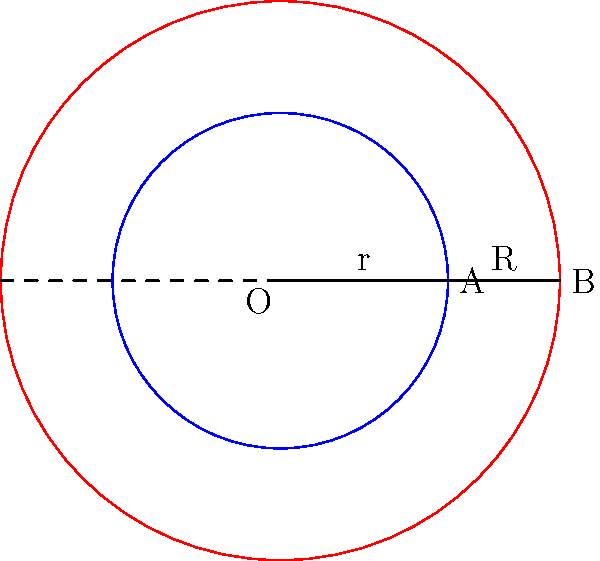In a city planning project, the radius of public services coverage is increased from $r$ to $R$. If the new area of coverage is 2.78 times the original area, what is the ratio of $R$ to $r$? Let's approach this step-by-step:

1) The area of a circle is given by the formula $A = \pi r^2$, where $r$ is the radius.

2) Let's call the original area $A_1$ and the new area $A_2$. We're told that $A_2 = 2.78A_1$.

3) We can express this mathematically:
   $\pi R^2 = 2.78 \pi r^2$

4) The $\pi$ cancels out on both sides:
   $R^2 = 2.78r^2$

5) To find the ratio of $R$ to $r$, we need to take the square root of both sides:
   $\sqrt{R^2} = \sqrt{2.78r^2}$
   $R = r\sqrt{2.78}$

6) The ratio $R:r$ is therefore $\sqrt{2.78} : 1$

7) To calculate this:
   $\sqrt{2.78} \approx 1.67$

Therefore, the ratio of $R$ to $r$ is approximately 1.67 to 1.
Answer: 1.67:1 